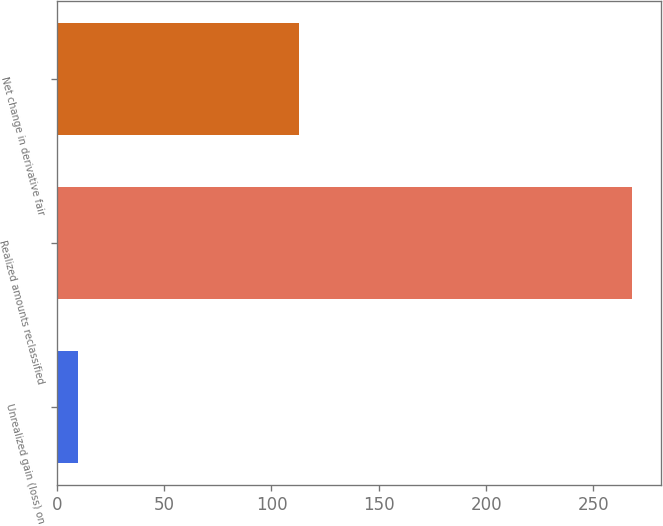<chart> <loc_0><loc_0><loc_500><loc_500><bar_chart><fcel>Unrealized gain (loss) on<fcel>Realized amounts reclassified<fcel>Net change in derivative fair<nl><fcel>10<fcel>268<fcel>113<nl></chart> 